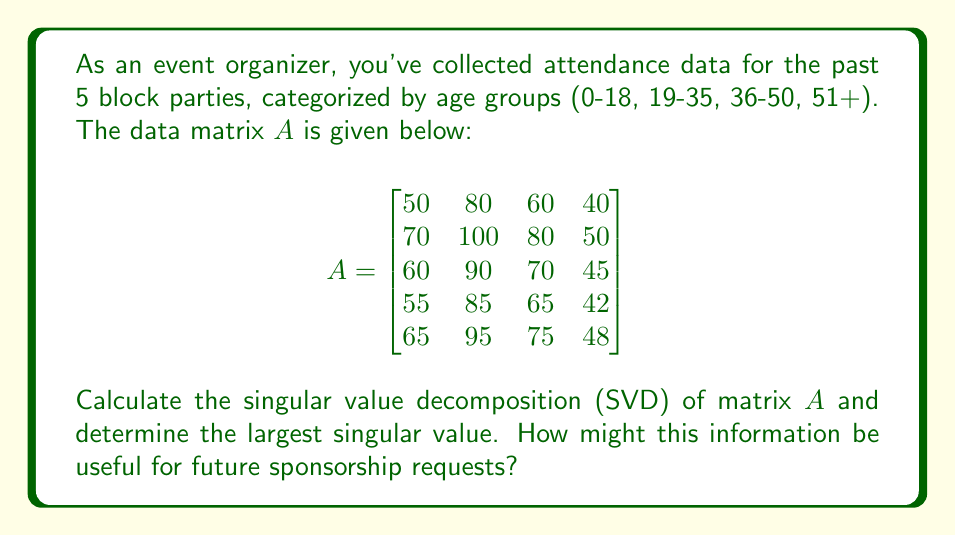What is the answer to this math problem? To find the singular value decomposition (SVD) of matrix $A$, we need to calculate $A = U\Sigma V^T$, where $U$ and $V$ are orthogonal matrices and $\Sigma$ is a diagonal matrix containing the singular values.

Step 1: Calculate $A^TA$
$$A^TA = \begin{bmatrix}
18550 & 29700 & 23250 & 14925 \\
29700 & 47600 & 37250 & 23925 \\
23250 & 37250 & 29175 & 18738 \\
14925 & 23925 & 18738 & 12029
\end{bmatrix}$$

Step 2: Find eigenvalues of $A^TA$
The characteristic equation is:
$\det(A^TA - \lambda I) = 0$

Solving this equation (using a computer algebra system due to its complexity) gives us the eigenvalues:
$\lambda_1 \approx 107403.8$
$\lambda_2 \approx 30.2$
$\lambda_3 \approx 0.0$
$\lambda_4 \approx 0.0$

Step 3: Calculate singular values
The singular values are the square roots of these eigenvalues:
$\sigma_1 \approx 327.7$
$\sigma_2 \approx 5.5$
$\sigma_3 \approx 0.0$
$\sigma_4 \approx 0.0$

Step 4: Construct $\Sigma$
$$\Sigma = \begin{bmatrix}
327.7 & 0 & 0 & 0 \\
0 & 5.5 & 0 & 0 \\
0 & 0 & 0 & 0 \\
0 & 0 & 0 & 0 \\
0 & 0 & 0 & 0
\end{bmatrix}$$

The largest singular value is 327.7.

This information can be useful for sponsorship requests in several ways:
1. The largest singular value (327.7) represents the overall scale of the event attendance, which can be used to demonstrate the event's reach to potential sponsors.
2. The significant gap between the first and second singular values suggests that the attendance pattern is relatively consistent across different age groups and years, which can be presented as evidence of the event's stability and broad appeal.
3. The right singular vectors (columns of V) corresponding to the largest singular values can reveal which age groups contribute most to the attendance, helping to target sponsors whose products or services align with these demographics.
Answer: 327.7 